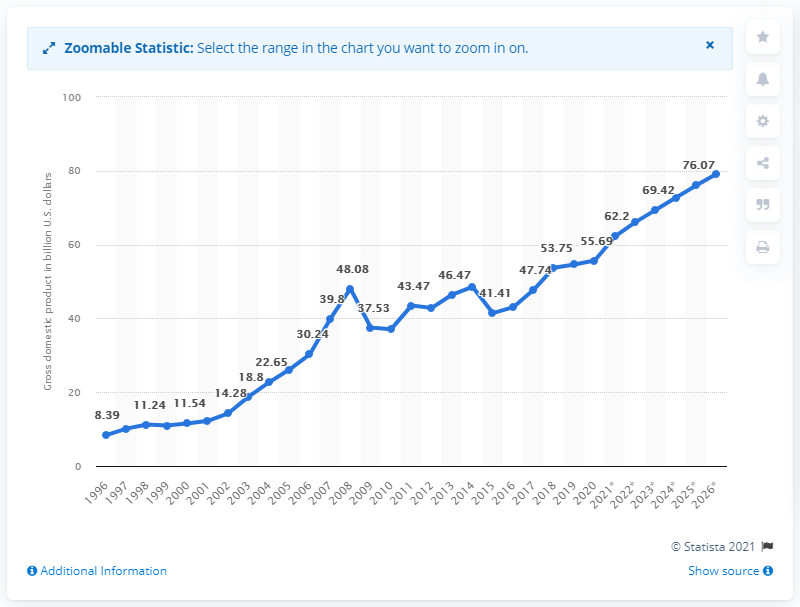Indicate a few pertinent items in this graphic. In 2020, Lithuania's Gross Domestic Product was estimated to be approximately 55.69 billion dollars. 